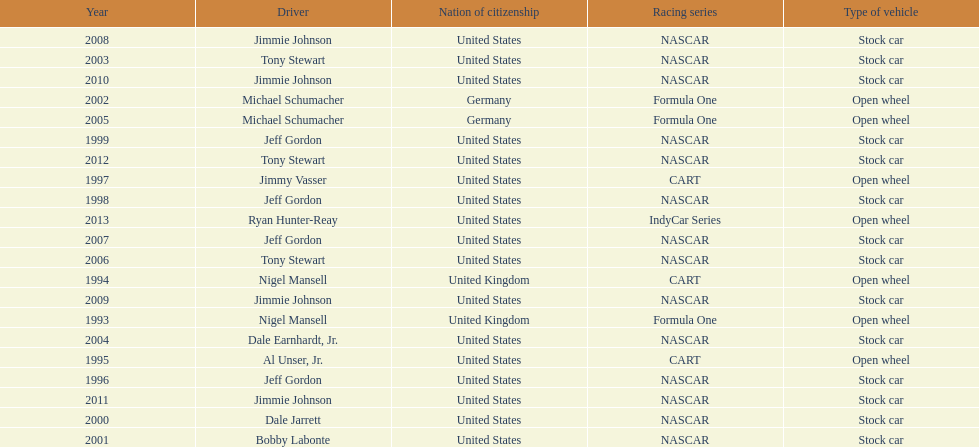Which driver won espy awards 11 years apart from each other? Jeff Gordon. 